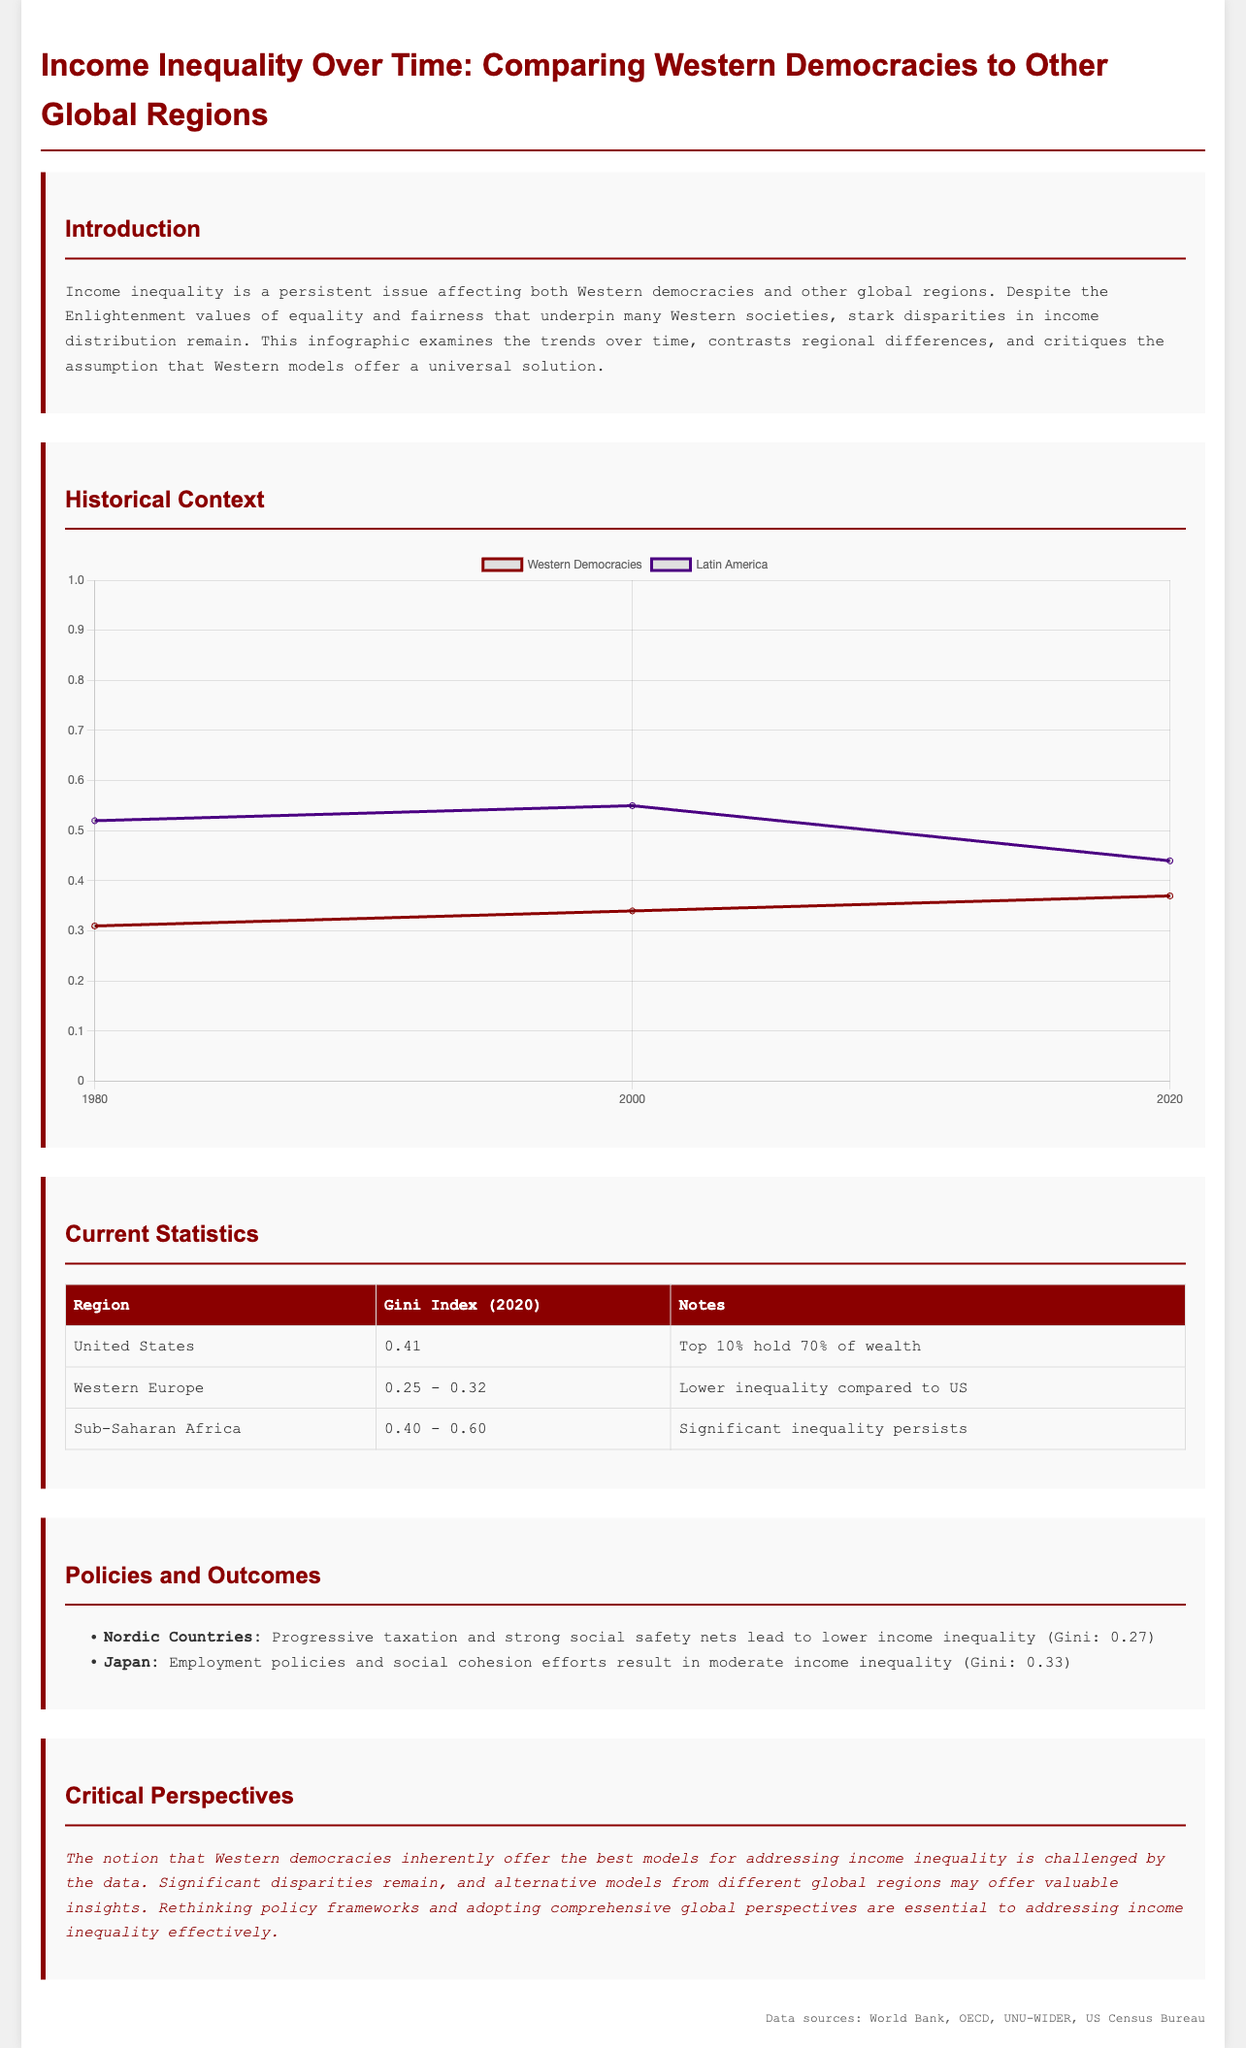what is the Gini Index for the United States in 2020? The Gini Index for the United States in 2020 is a specific figure displayed in the document, which is 0.41.
Answer: 0.41 what is the Gini Index range for Western Europe in 2020? The document specifies the Gini Index range for Western Europe in 2020 as a value between 0.25 and 0.32.
Answer: 0.25 - 0.32 what percentage of wealth does the top 10% hold in the United States? The document states that the top 10% in the United States hold 70% of wealth.
Answer: 70% what Gini Index value is reported for Nordic countries? The Gini Index reported for Nordic countries is mentioned in the document as 0.27.
Answer: 0.27 how did Gini Index change for Western Democracies from 1980 to 2020? The document shows that the Gini Index for Western Democracies increased from 0.31 in 1980 to 0.37 in 2020, indicating a rise in inequality.
Answer: Increased what is the main critique of Western democracies regarding income inequality according to the document? The document critiques the notion that Western democracies inherently offer the best models for addressing income inequality, citing significant disparities and the potential of alternative models.
Answer: Best models which global region is noted to have significant inequality that persists? The document specifies Sub-Saharan Africa as a region where significant inequality persists.
Answer: Sub-Saharan Africa what is the Gini Index for Japan according to the policies and outcomes section? In the Policies and Outcomes section of the document, Japan's Gini Index is reported as 0.33.
Answer: 0.33 what type of chart is displayed to show the historical trends over time? The chart in the Historical Context section is identified as a line chart demonstrating Gini Index trends.
Answer: Line chart 